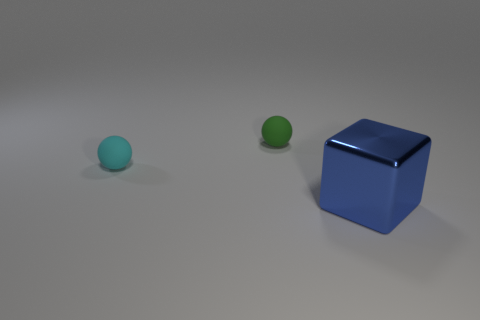Add 1 tiny green spheres. How many objects exist? 4 Subtract all blocks. How many objects are left? 2 Add 3 large blocks. How many large blocks exist? 4 Subtract 0 blue cylinders. How many objects are left? 3 Subtract all large cyan rubber things. Subtract all green matte things. How many objects are left? 2 Add 2 blue blocks. How many blue blocks are left? 3 